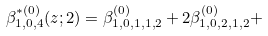<formula> <loc_0><loc_0><loc_500><loc_500>\beta ^ { \ast ( 0 ) } _ { 1 , 0 , 4 } ( z ; 2 ) = \beta _ { 1 , 0 , 1 , 1 , 2 } ^ { ( 0 ) } + 2 \beta _ { 1 , 0 , 2 , 1 , 2 } ^ { ( 0 ) } +</formula> 